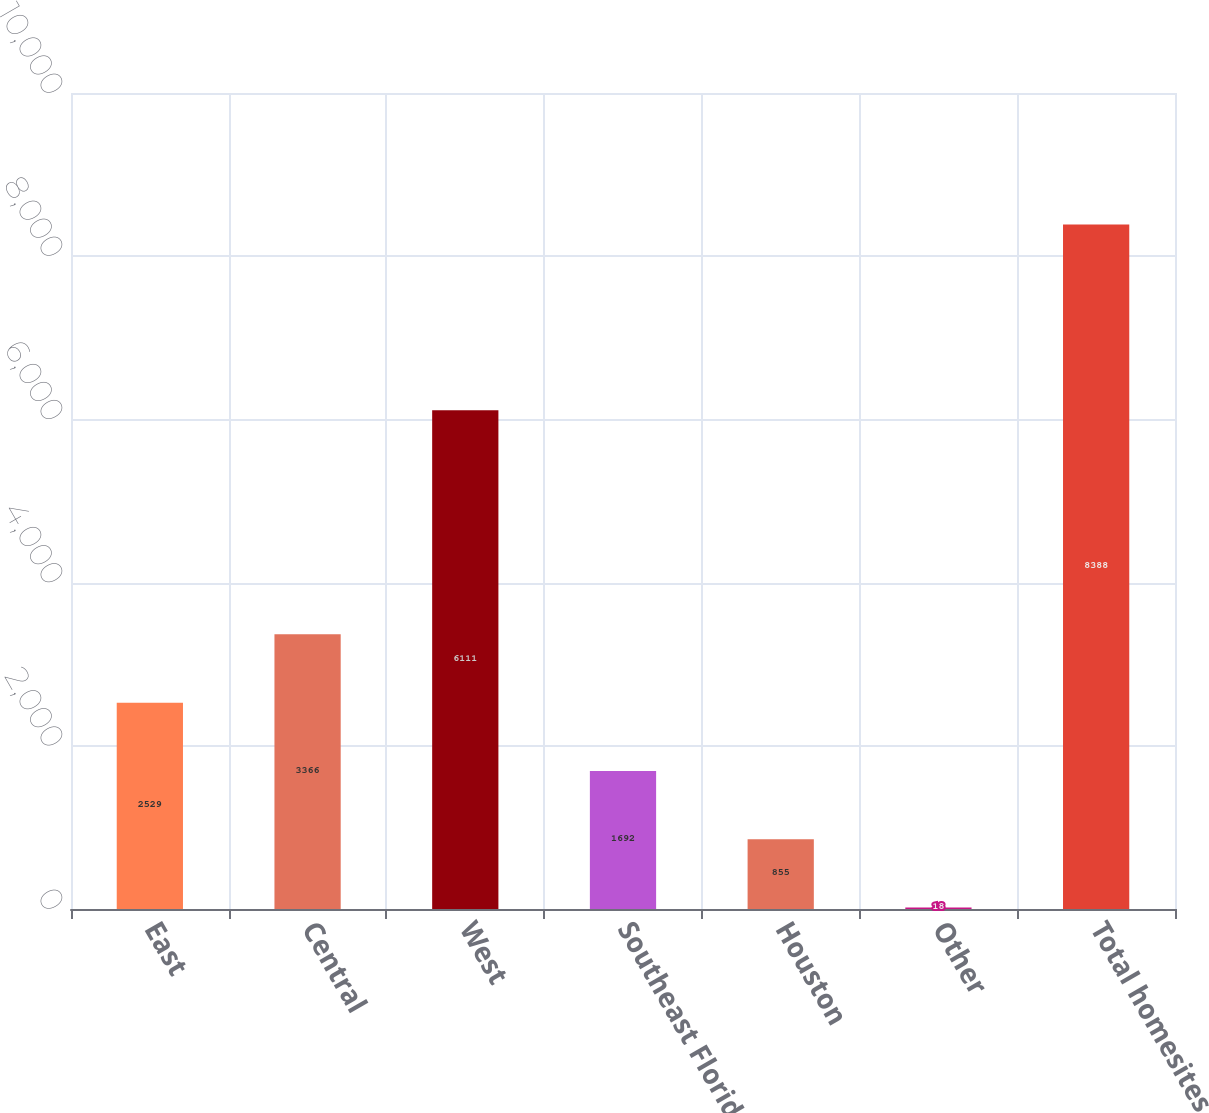<chart> <loc_0><loc_0><loc_500><loc_500><bar_chart><fcel>East<fcel>Central<fcel>West<fcel>Southeast Florida<fcel>Houston<fcel>Other<fcel>Total homesites<nl><fcel>2529<fcel>3366<fcel>6111<fcel>1692<fcel>855<fcel>18<fcel>8388<nl></chart> 